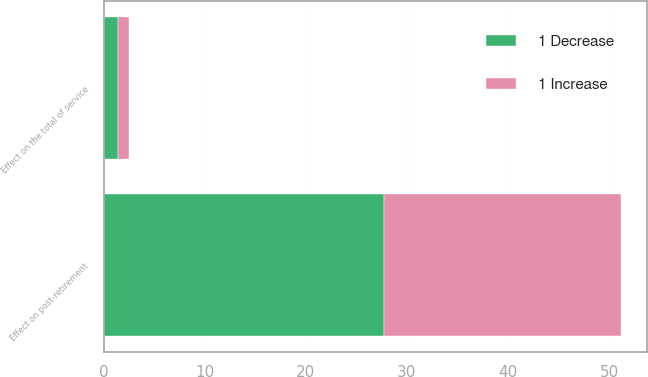<chart> <loc_0><loc_0><loc_500><loc_500><stacked_bar_chart><ecel><fcel>Effect on the total of service<fcel>Effect on post-retirement<nl><fcel>1 Decrease<fcel>1.4<fcel>27.7<nl><fcel>1 Increase<fcel>1.1<fcel>23.5<nl></chart> 